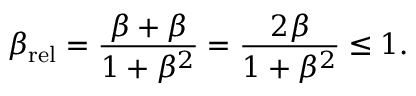<formula> <loc_0><loc_0><loc_500><loc_500>\beta _ { r e l } = { \frac { \beta + \beta } { 1 + \beta ^ { 2 } } } = { \frac { 2 \beta } { 1 + \beta ^ { 2 } } } \leq 1 .</formula> 